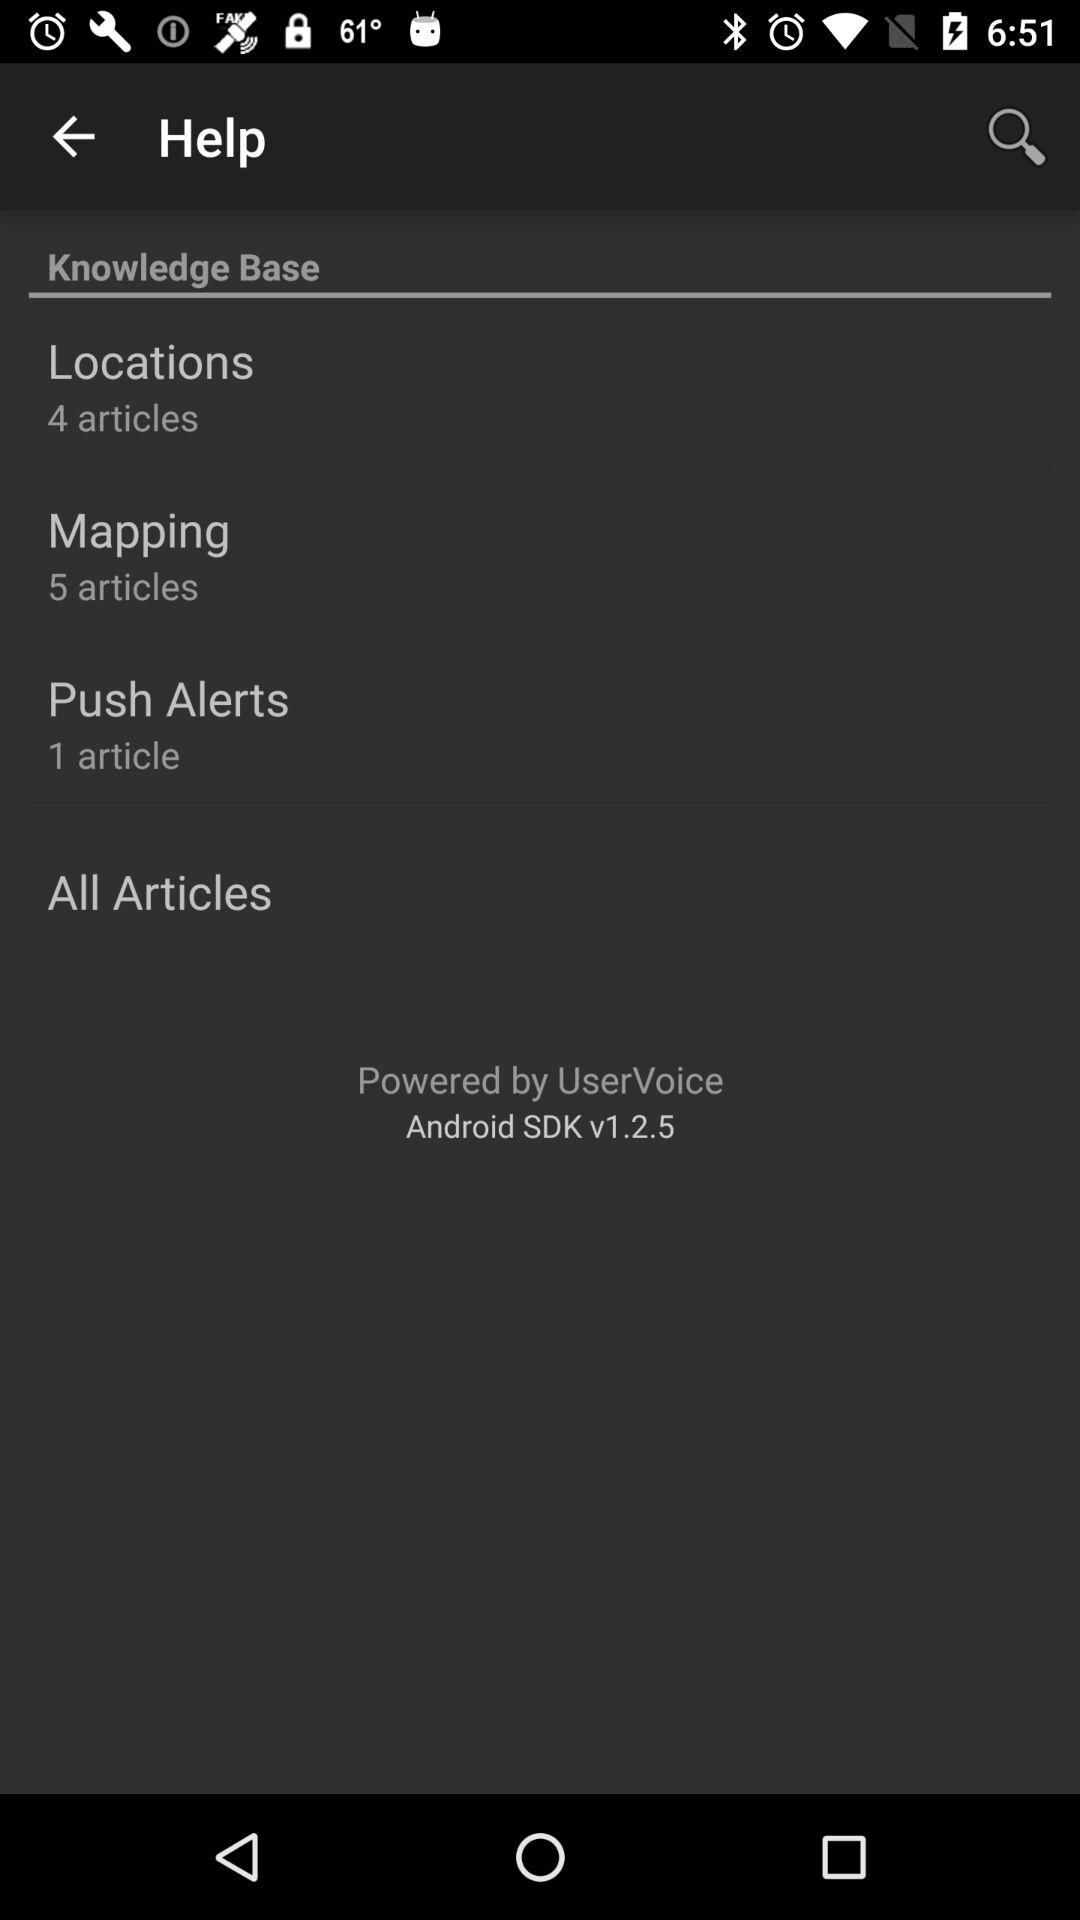How many articles are in the Knowledge Base?
Answer the question using a single word or phrase. 10 